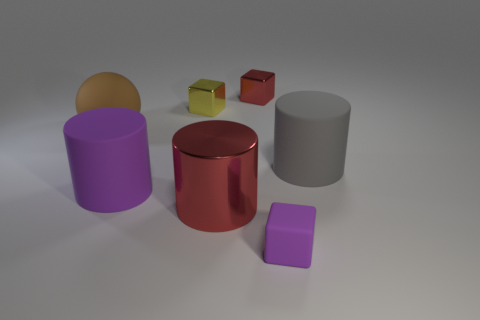Add 1 big green matte blocks. How many objects exist? 8 Subtract all rubber objects. Subtract all tiny red shiny blocks. How many objects are left? 2 Add 7 big balls. How many big balls are left? 8 Add 2 tiny blocks. How many tiny blocks exist? 5 Subtract 1 red blocks. How many objects are left? 6 Subtract all blocks. How many objects are left? 4 